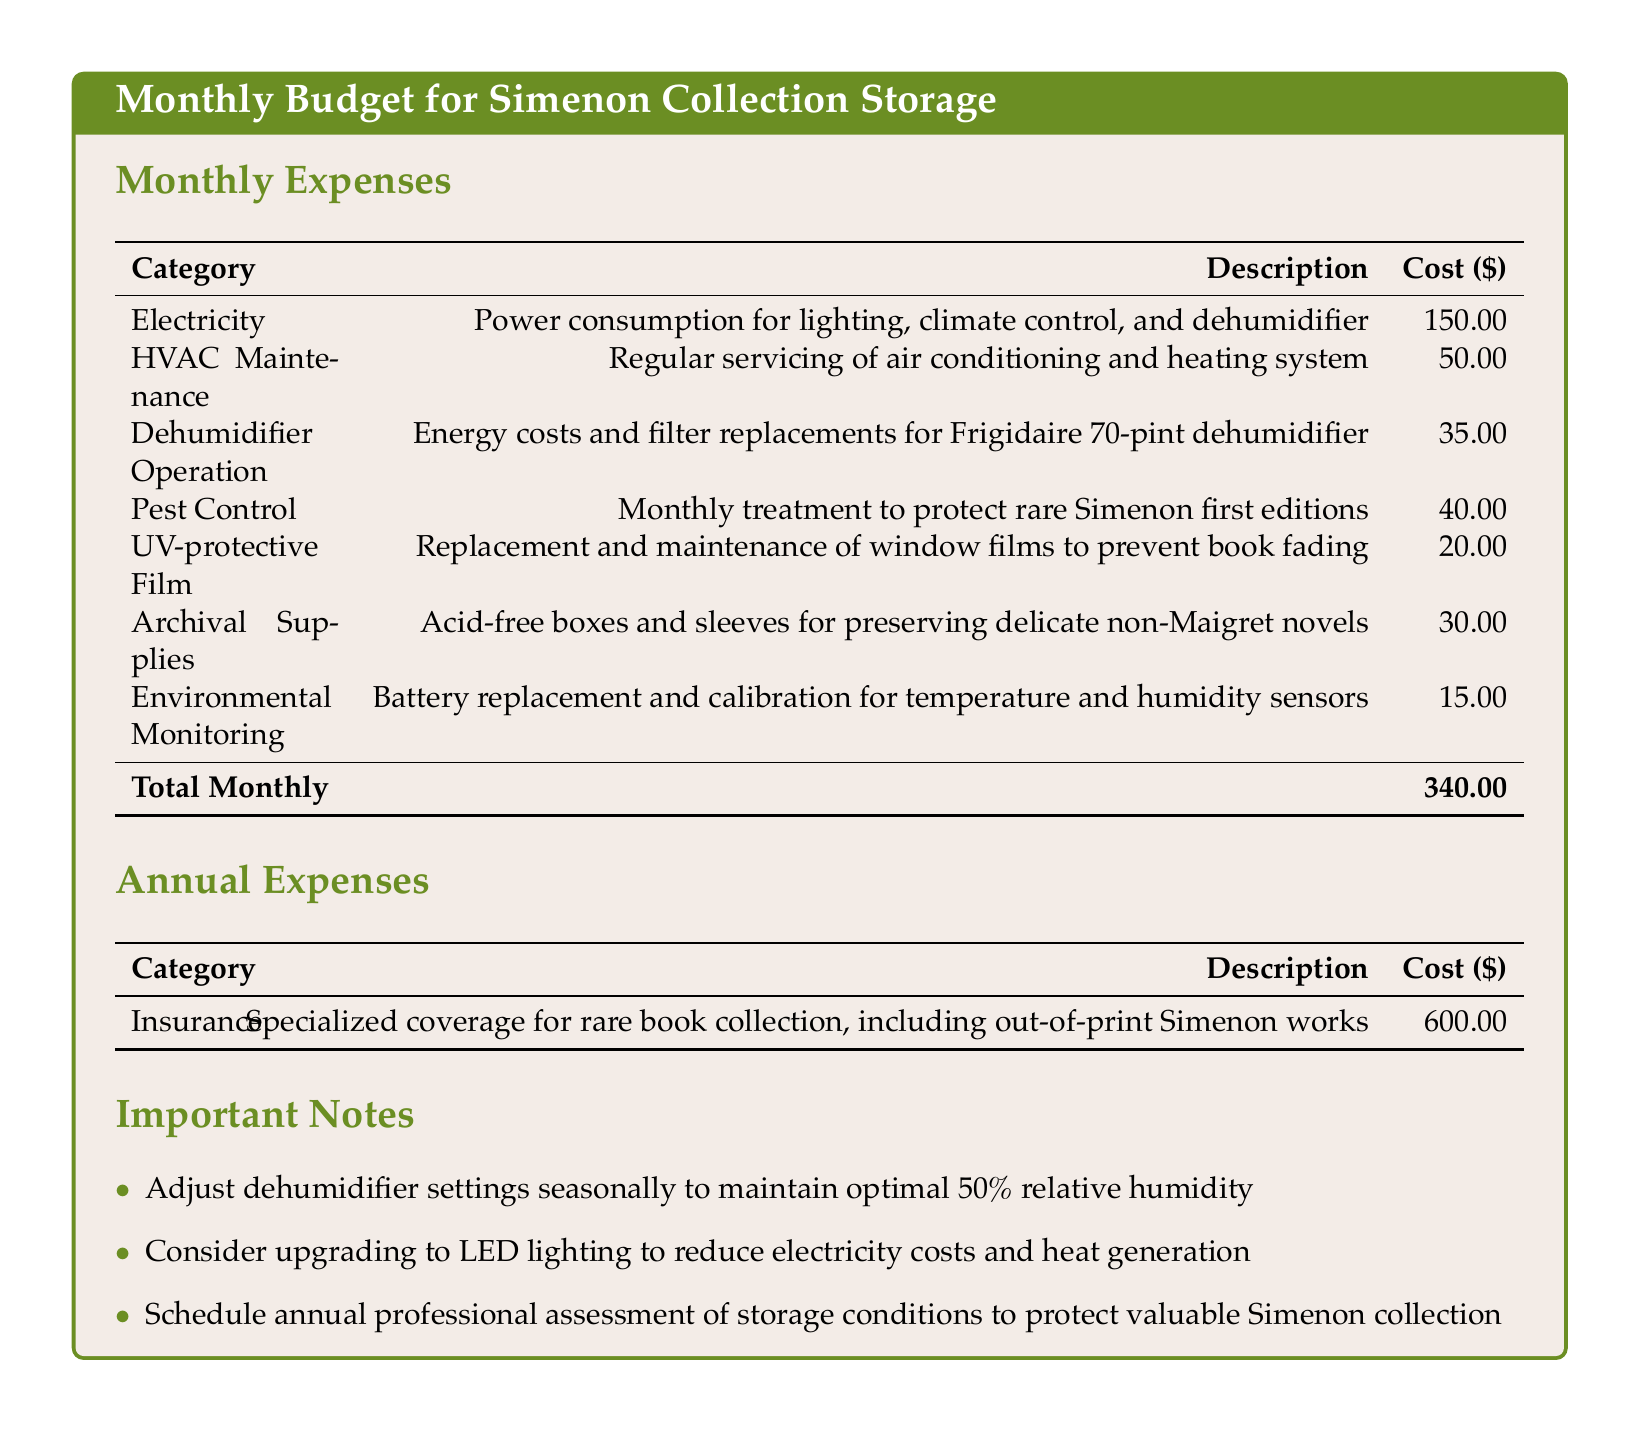What is the total monthly expense? The total monthly expense is clearly stated in the document as the sum of all monthly costs listed.
Answer: 340.00 How much is spent on electricity? The document specifies that electricity costs for lighting, climate control, and dehumidifier are mentioned as a separate line item.
Answer: 150.00 What category has the highest monthly cost? By examining the monthly expenses, electricity stands out as the category with the largest cost.
Answer: Electricity How much is allocated for pest control? Pest control is listed with its specific monthly cost in the budget table.
Answer: 40.00 What is the annual cost for insurance? The document provides the cost for insurance as an annual expense, detailing protection for the rare book collection.
Answer: 600.00 How much is the dehumidifier operation cost? Dehumidifier operation costs, listed in the monthly expenses, indicate the energy costs related to its use.
Answer: 35.00 What is advised to reduce electricity costs? One of the notes in the document suggests an upgrade to a more efficient lighting system.
Answer: Upgrade to LED lighting What is the recommended relative humidity level for optimal preservation? The important notes section of the document specifies the ideal conditions for book storage regarding humidity.
Answer: 50% What is included in the archival supplies cost? The document describes what the archival supplies consist of in terms of their function for book preservation.
Answer: Acid-free boxes and sleeves 